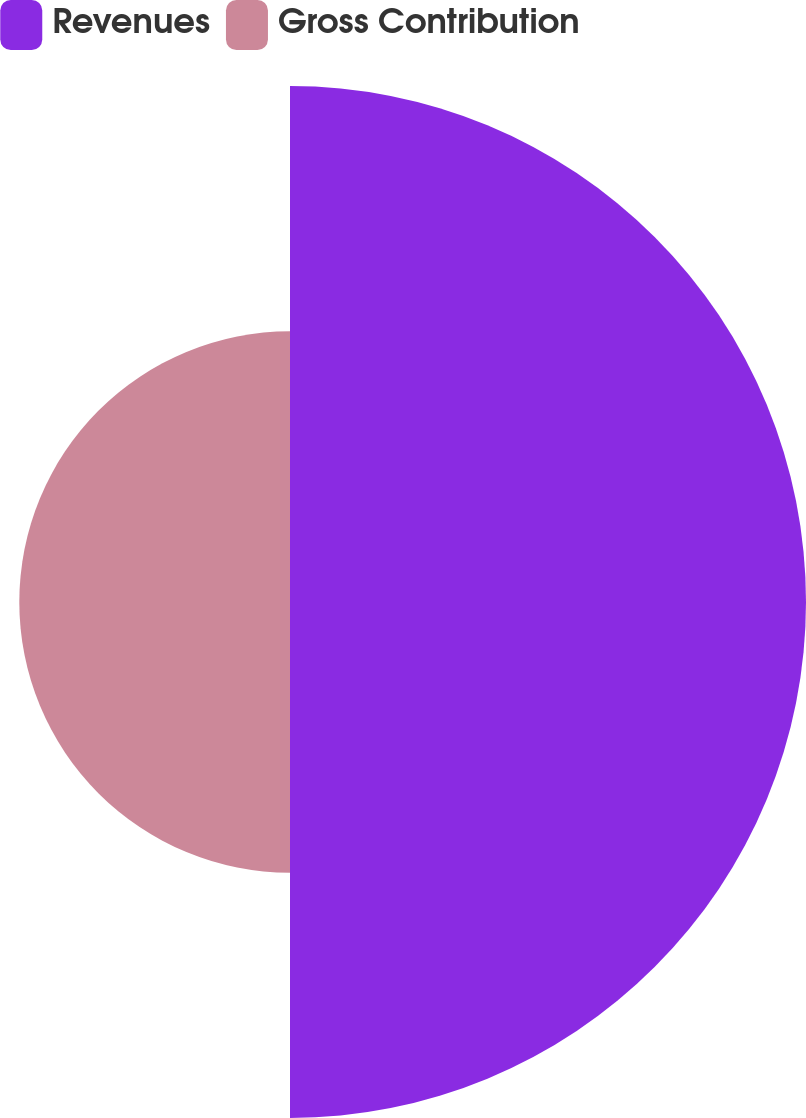<chart> <loc_0><loc_0><loc_500><loc_500><pie_chart><fcel>Revenues<fcel>Gross Contribution<nl><fcel>65.59%<fcel>34.41%<nl></chart> 